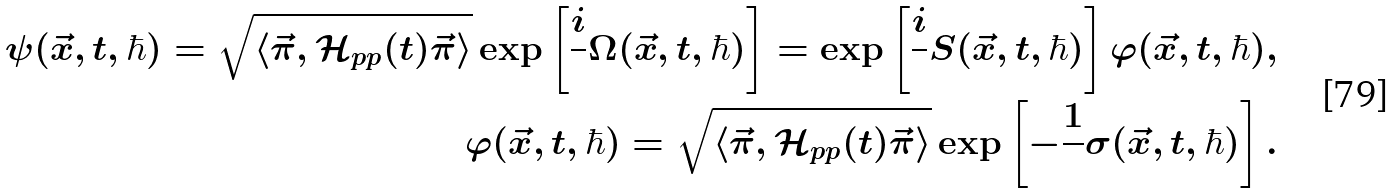Convert formula to latex. <formula><loc_0><loc_0><loc_500><loc_500>\psi ( \vec { x } , t , \hbar { ) } = \sqrt { \langle \vec { \pi } , \mathcal { H } _ { p p } ( t ) \vec { \pi } \rangle } \exp \left [ { \frac { i } { } \Omega ( \vec { x } , t , \hbar { ) } } \right ] = \exp \left [ \frac { i } { } S ( \vec { x } , t , \hbar { ) } \right ] \varphi ( \vec { x } , t , \hbar { ) } , \\ \varphi ( \vec { x } , t , \hbar { ) } = \sqrt { \langle \vec { \pi } , { \mathcal { H } } _ { p p } ( t ) \vec { \pi } \rangle } \exp \left [ { - \frac { 1 } { } \sigma ( \vec { x } , t , \hbar { ) } } \right ] .</formula> 